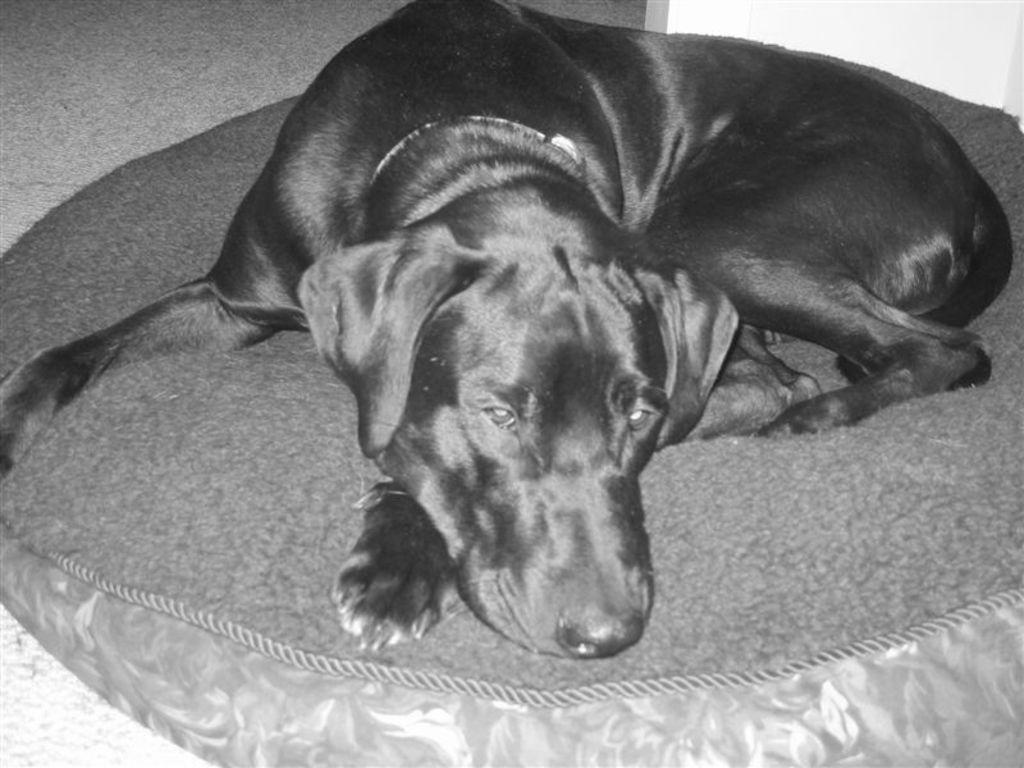Please provide a concise description of this image. This picture seems to be clicked inside. In the center there is a dog seems to be lying on an object. In the background there is a wall. 